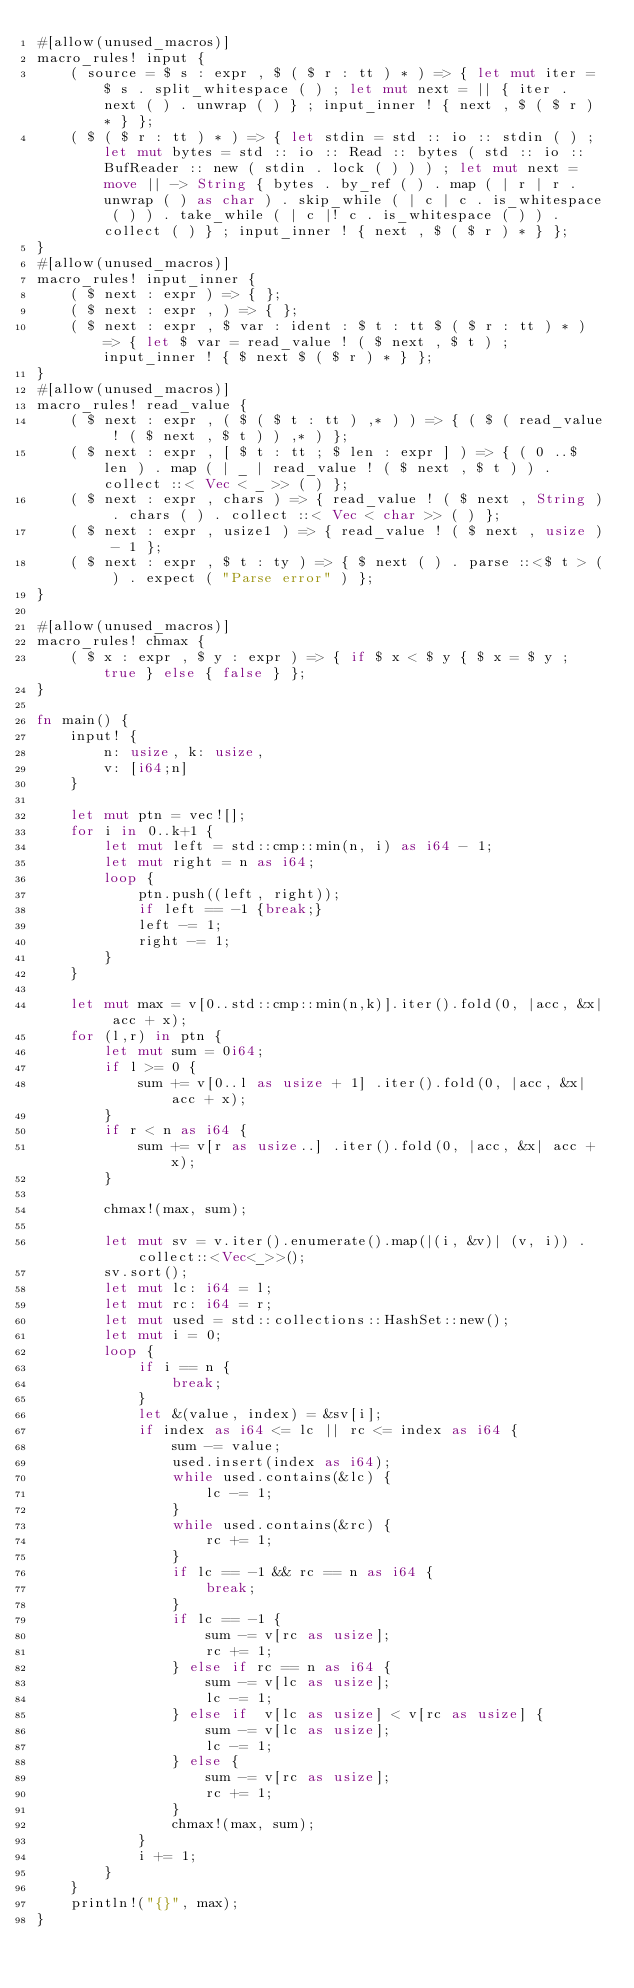Convert code to text. <code><loc_0><loc_0><loc_500><loc_500><_Rust_>#[allow(unused_macros)]
macro_rules! input {
    ( source = $ s : expr , $ ( $ r : tt ) * ) => { let mut iter = $ s . split_whitespace ( ) ; let mut next = || { iter . next ( ) . unwrap ( ) } ; input_inner ! { next , $ ( $ r ) * } };
    ( $ ( $ r : tt ) * ) => { let stdin = std :: io :: stdin ( ) ; let mut bytes = std :: io :: Read :: bytes ( std :: io :: BufReader :: new ( stdin . lock ( ) ) ) ; let mut next = move || -> String { bytes . by_ref ( ) . map ( | r | r . unwrap ( ) as char ) . skip_while ( | c | c . is_whitespace ( ) ) . take_while ( | c |! c . is_whitespace ( ) ) . collect ( ) } ; input_inner ! { next , $ ( $ r ) * } };
}
#[allow(unused_macros)]
macro_rules! input_inner {
    ( $ next : expr ) => { };
    ( $ next : expr , ) => { };
    ( $ next : expr , $ var : ident : $ t : tt $ ( $ r : tt ) * ) => { let $ var = read_value ! ( $ next , $ t ) ; input_inner ! { $ next $ ( $ r ) * } };
}
#[allow(unused_macros)]
macro_rules! read_value {
    ( $ next : expr , ( $ ( $ t : tt ) ,* ) ) => { ( $ ( read_value ! ( $ next , $ t ) ) ,* ) };
    ( $ next : expr , [ $ t : tt ; $ len : expr ] ) => { ( 0 ..$ len ) . map ( | _ | read_value ! ( $ next , $ t ) ) . collect ::< Vec < _ >> ( ) };
    ( $ next : expr , chars ) => { read_value ! ( $ next , String ) . chars ( ) . collect ::< Vec < char >> ( ) };
    ( $ next : expr , usize1 ) => { read_value ! ( $ next , usize ) - 1 };
    ( $ next : expr , $ t : ty ) => { $ next ( ) . parse ::<$ t > ( ) . expect ( "Parse error" ) };
}

#[allow(unused_macros)]
macro_rules! chmax {
    ( $ x : expr , $ y : expr ) => { if $ x < $ y { $ x = $ y ; true } else { false } };
}

fn main() {
    input! {
        n: usize, k: usize,
        v: [i64;n]
    }

    let mut ptn = vec![];
    for i in 0..k+1 {
        let mut left = std::cmp::min(n, i) as i64 - 1;
        let mut right = n as i64;
        loop {
            ptn.push((left, right));
            if left == -1 {break;}
            left -= 1;
            right -= 1;
        }
    }

    let mut max = v[0..std::cmp::min(n,k)].iter().fold(0, |acc, &x| acc + x);
    for (l,r) in ptn {
        let mut sum = 0i64;
        if l >= 0 {
            sum += v[0..l as usize + 1] .iter().fold(0, |acc, &x| acc + x);
        }
        if r < n as i64 {
            sum += v[r as usize..] .iter().fold(0, |acc, &x| acc + x);
        }

        chmax!(max, sum);

        let mut sv = v.iter().enumerate().map(|(i, &v)| (v, i)) .collect::<Vec<_>>();
        sv.sort();
        let mut lc: i64 = l;
        let mut rc: i64 = r;
        let mut used = std::collections::HashSet::new();
        let mut i = 0;
        loop {
            if i == n {
                break;
            }
            let &(value, index) = &sv[i];
            if index as i64 <= lc || rc <= index as i64 {
                sum -= value;
                used.insert(index as i64);
                while used.contains(&lc) {
                    lc -= 1;
                }
                while used.contains(&rc) {
                    rc += 1;
                }
                if lc == -1 && rc == n as i64 {
                    break;
                }
                if lc == -1 {
                    sum -= v[rc as usize];
                    rc += 1;
                } else if rc == n as i64 {
                    sum -= v[lc as usize];
                    lc -= 1;
                } else if  v[lc as usize] < v[rc as usize] {
                    sum -= v[lc as usize];
                    lc -= 1;
                } else {
                    sum -= v[rc as usize];
                    rc += 1;
                }
                chmax!(max, sum);
            }
            i += 1;
        }
    }
    println!("{}", max);
}
</code> 